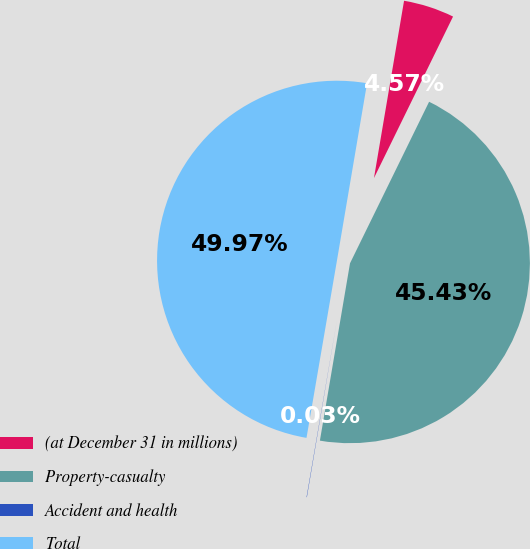Convert chart. <chart><loc_0><loc_0><loc_500><loc_500><pie_chart><fcel>(at December 31 in millions)<fcel>Property-casualty<fcel>Accident and health<fcel>Total<nl><fcel>4.57%<fcel>45.43%<fcel>0.03%<fcel>49.97%<nl></chart> 